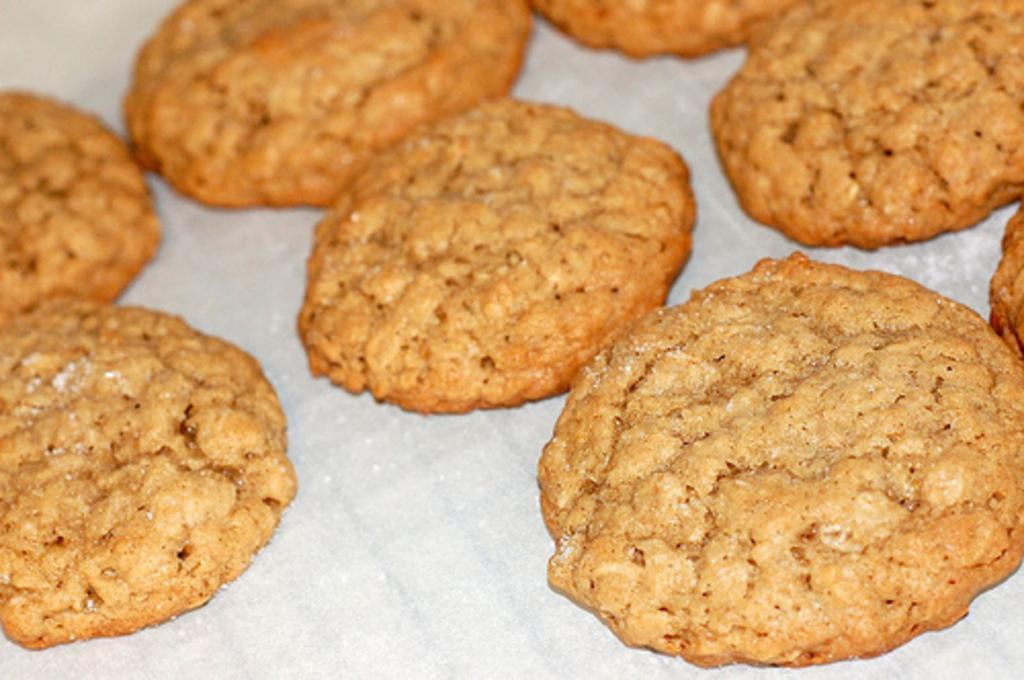Describe this image in one or two sentences. In this picture we can see cookies on a white surface. 